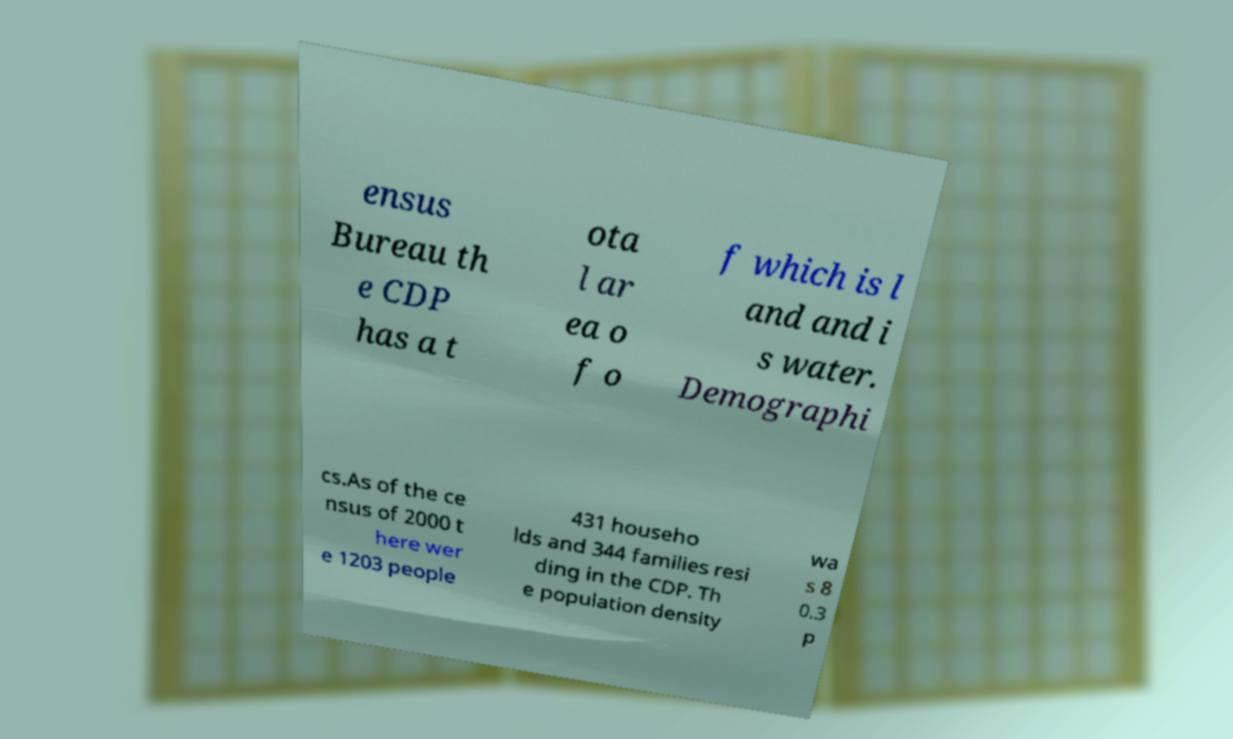Can you accurately transcribe the text from the provided image for me? ensus Bureau th e CDP has a t ota l ar ea o f o f which is l and and i s water. Demographi cs.As of the ce nsus of 2000 t here wer e 1203 people 431 househo lds and 344 families resi ding in the CDP. Th e population density wa s 8 0.3 p 